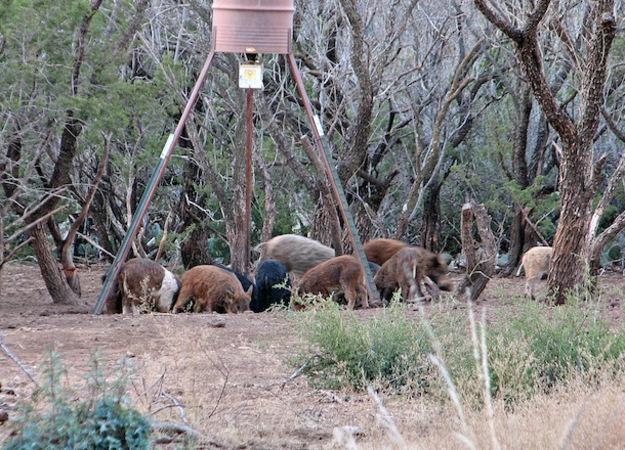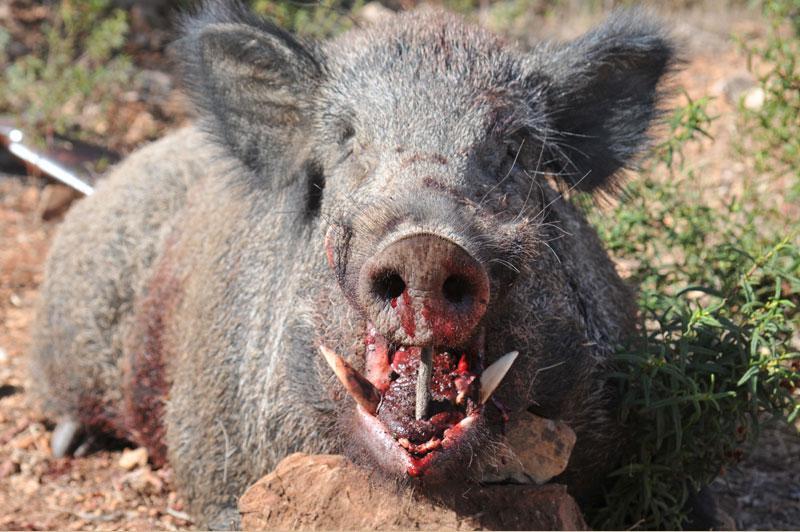The first image is the image on the left, the second image is the image on the right. Examine the images to the left and right. Is the description "There are two hogs in total." accurate? Answer yes or no. No. The first image is the image on the left, the second image is the image on the right. Considering the images on both sides, is "All pigs shown in the images face the same direction." valid? Answer yes or no. No. 